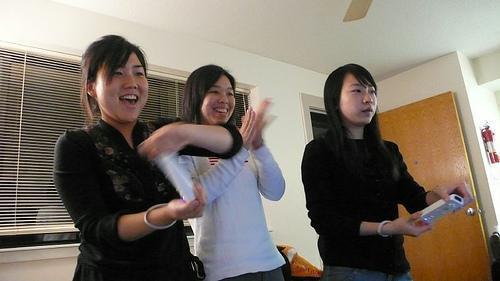How many girls are holding video game controllers?
Give a very brief answer. 2. How many people are there?
Give a very brief answer. 3. How many chairs in this image are not placed at the table by the window?
Give a very brief answer. 0. 